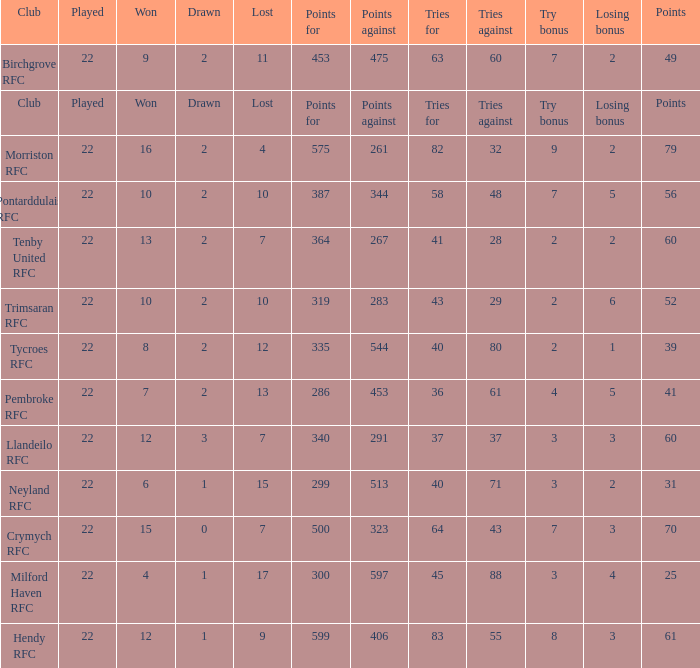 how many losing bonus with won being 10 and points against being 283 1.0. 